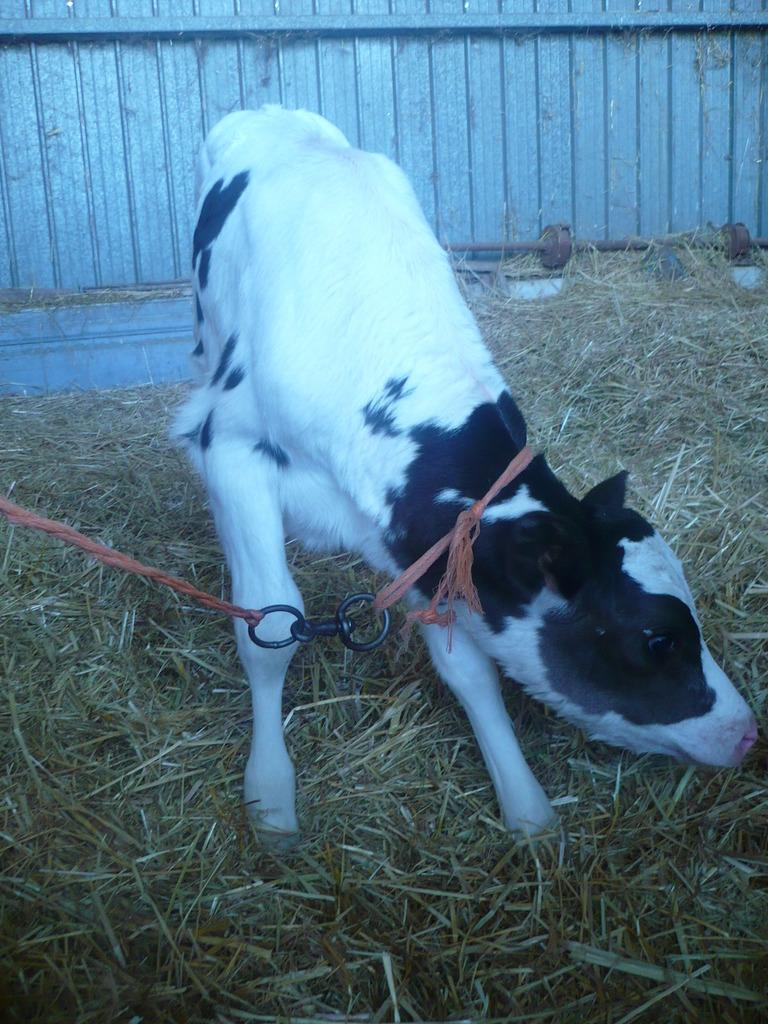What animal is present in the picture? There is a calf in the picture. What type of vegetation can be seen in the picture? There is dry grass in the picture. Is there anything attached to the calf? Yes, the calf has a string around its neck. What can be seen in the background of the picture? There appears to be a wall in the background of the picture. What type of comfort does the calf need in the picture? The image does not provide information about the calf's comfort needs. 